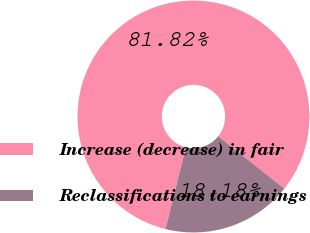<chart> <loc_0><loc_0><loc_500><loc_500><pie_chart><fcel>Increase (decrease) in fair<fcel>Reclassifications to earnings<nl><fcel>81.82%<fcel>18.18%<nl></chart> 